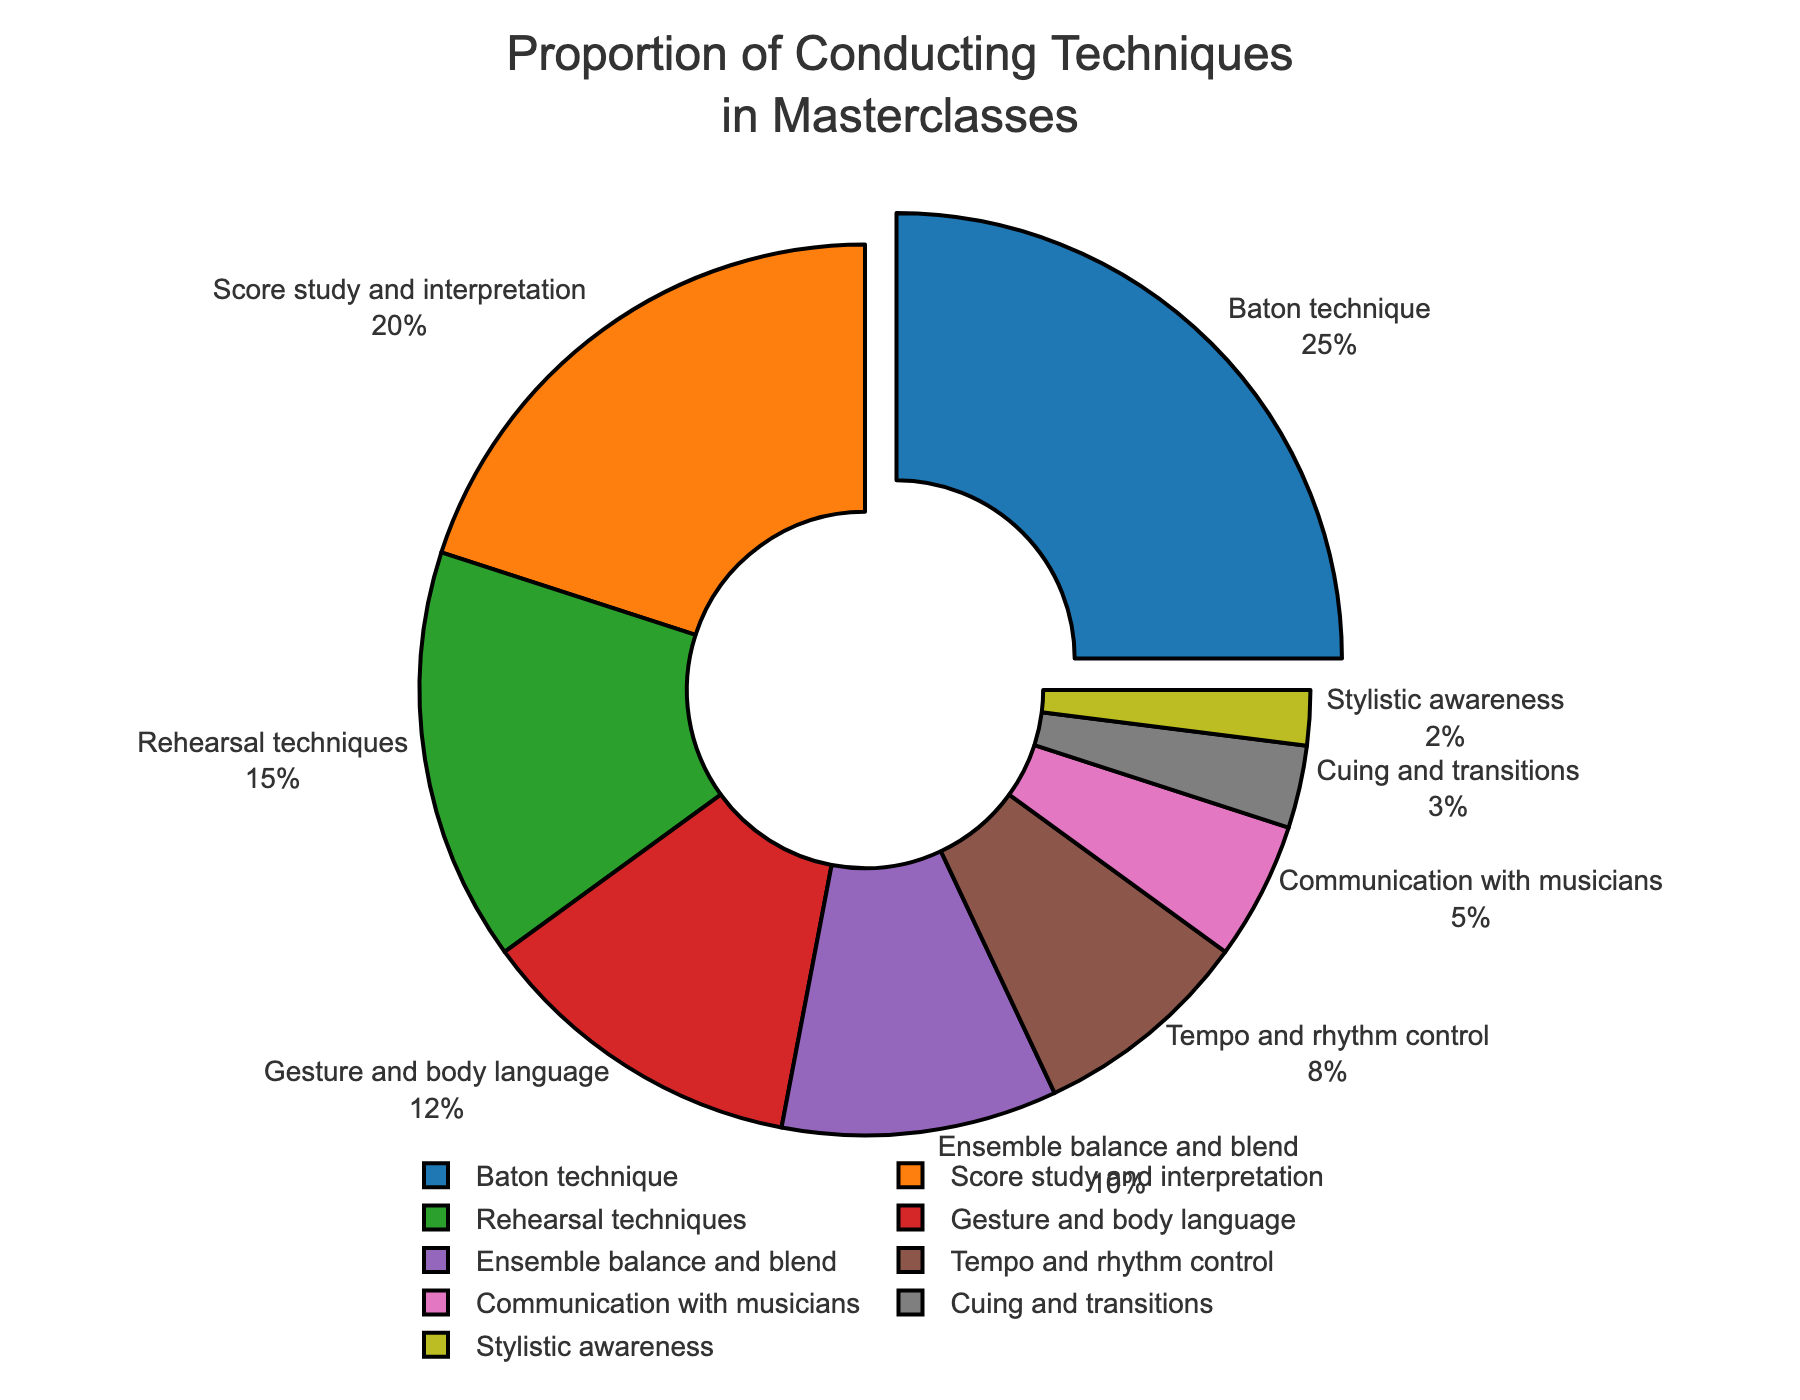What is the most frequently taught conducting technique in masterclasses? The "Baton technique" has the largest slice in the pie chart, indicating it's the most taught technique, representing 25% of the total.
Answer: Baton technique Compare the proportions of "Rehearsal techniques" and "Gesture and body language." "Rehearsal techniques" occupy 15% of the chart, while "Gesture and body language" occupy 12%, indicating that "Rehearsal techniques" is taught more frequently.
Answer: Rehearsal techniques If you combine the percentages of "Tempo and rhythm control" and "Communication with musicians," what is the total percentage? "Tempo and rhythm control" is 8%, and "Communication with musicians" is 5%. Adding these together gives 8% + 5% = 13%.
Answer: 13% Which technique has the smallest proportion, and what is its percentage? The smallest slice in the pie chart represents "Stylistic awareness," which accounts for 2%.
Answer: Stylistic awareness, 2% How much more is the percentage of "Baton technique" compared to "Cuing and transitions"? "Baton technique" is 25% and "Cuing and transitions" is 3%. The difference is 25% - 3% = 22%.
Answer: 22% What is the cumulative percentage of the three least frequently taught techniques? The three least frequently taught techniques are "Stylistic awareness" (2%), "Cuing and transitions" (3%), and "Communication with musicians" (5%). Adding them gives 2% + 3% + 5% = 10%.
Answer: 10% Is the percentage of "Ensemble balance and blend" greater than that of "Tempo and rhythm control"? "Ensemble balance and blend" accounts for 10%, and "Tempo and rhythm control" accounts for 8%. Therefore, "Ensemble balance and blend" is greater.
Answer: Yes What combination of techniques forms a total of 45%? The techniques "Baton technique" (25%), "Score study and interpretation" (20%), combining gives a total of 25% + 20% = 45%.
Answer: Baton technique and Score study and interpretation 